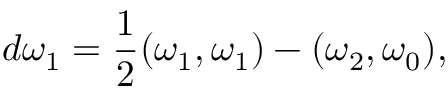Convert formula to latex. <formula><loc_0><loc_0><loc_500><loc_500>d \omega _ { 1 } = { \frac { 1 } { 2 } } ( \omega _ { 1 } , \omega _ { 1 } ) - ( \omega _ { 2 } , \omega _ { 0 } ) ,</formula> 